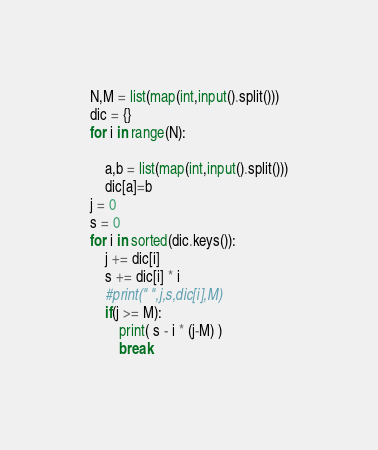Convert code to text. <code><loc_0><loc_0><loc_500><loc_500><_Python_>N,M = list(map(int,input().split()))
dic = {}
for i in range(N):
    
    a,b = list(map(int,input().split()))
    dic[a]=b
j = 0
s = 0
for i in sorted(dic.keys()):
    j += dic[i]
    s += dic[i] * i
    #print(" ",j,s,dic[i],M)
    if(j >= M):
        print( s - i * (j-M) )
        break</code> 